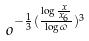<formula> <loc_0><loc_0><loc_500><loc_500>o ^ { - \frac { 1 } { 3 } ( \frac { \log \frac { x } { x _ { 6 } } } { \log \varpi } ) ^ { 3 } }</formula> 